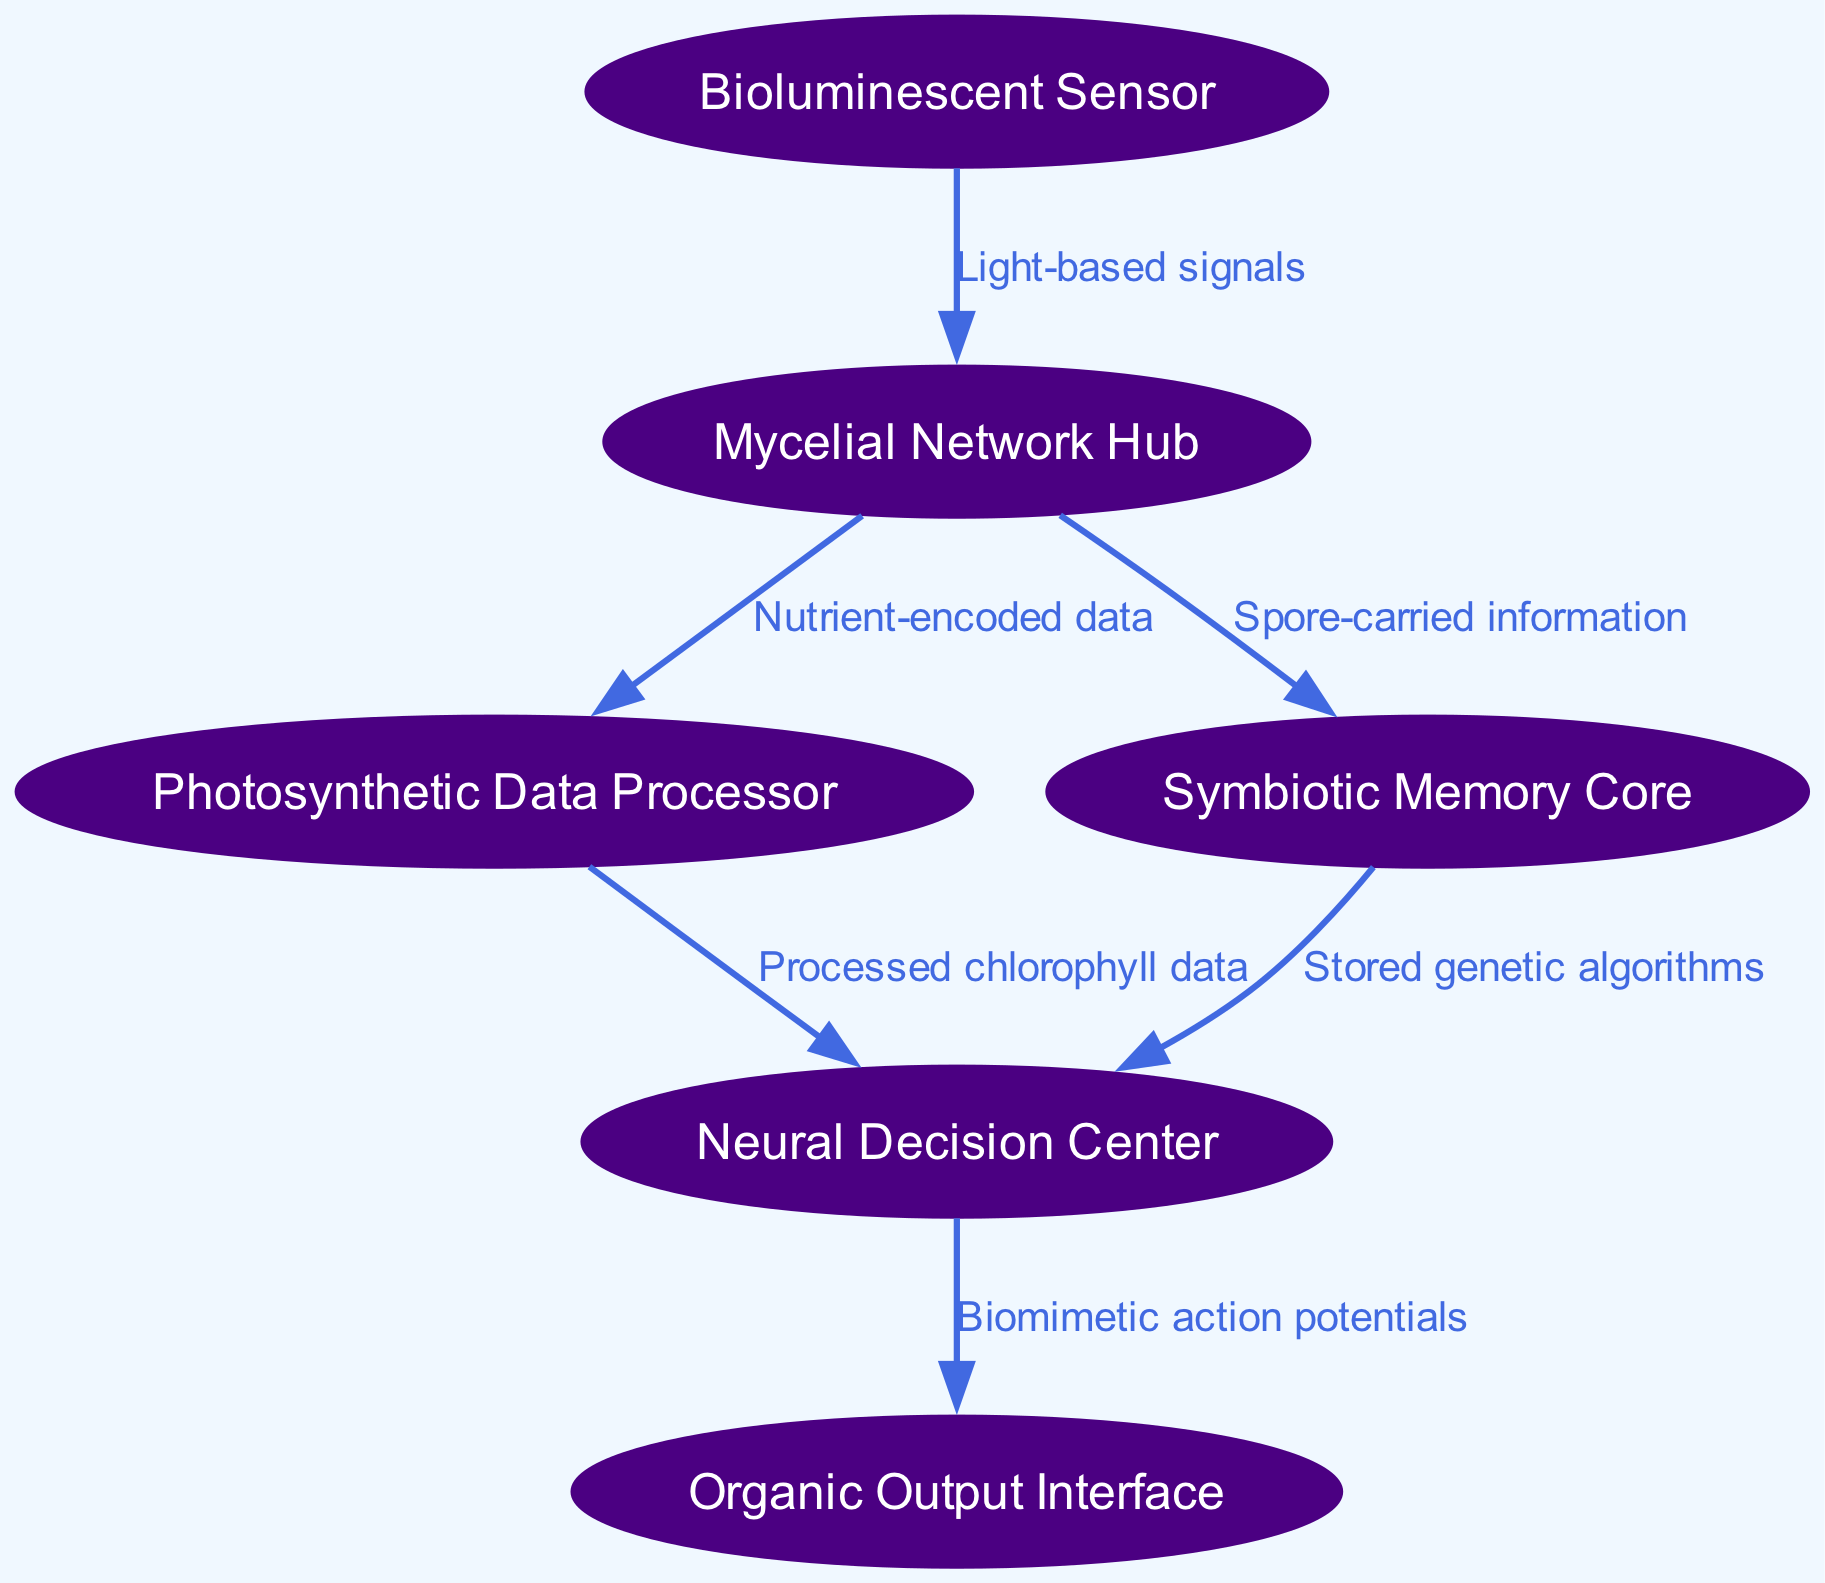What is the total number of nodes in the diagram? By counting each entry in the 'nodes' list within the provided data, we find there are six distinct nodes labeled: Bioluminescent Sensor, Mycelial Network Hub, Photosynthetic Data Processor, Symbiotic Memory Core, Neural Decision Center, and Organic Output Interface.
Answer: 6 What type of signal does the Bioluminescent Sensor use to communicate? The label on the edge from the Bioluminescent Sensor to the Mycelial Network Hub indicates that the communication method employed is "Light-based signals."
Answer: Light-based signals Which node receives nutrient-encoded data from the Mycelial Network Hub? The directed edge from the Mycelial Network Hub shows it sends nutrient-encoded data to the Photosynthetic Data Processor, indicating that this is the node receiving such data.
Answer: Photosynthetic Data Processor How many edges connect the Neural Decision Center to other nodes? By inspecting the outgoing connections from the Neural Decision Center, the diagram shows a single edge leading to the Organic Output Interface, indicating that it is connected to only one other node.
Answer: 1 What is passed between the Symbiotic Memory Core and the Neural Decision Center? The edge from the Symbiotic Memory Core to the Neural Decision Center indicates that "Stored genetic algorithms" are transferred between these two nodes.
Answer: Stored genetic algorithms What does the Photosynthetic Data Processor send to the Neural Decision Center? The edge from the Photosynthetic Data Processor to the Neural Decision Center specifies that it passes "Processed chlorophyll data" to the decision center, which highlights the nature of the data flow in this ecosystem.
Answer: Processed chlorophyll data Which node acts as the interface for organic output in the ecosystem? The label of the last node, which receives inputs from the Neural Decision Center, is explicitly marked as the "Organic Output Interface," denoting its role in the ecosystem.
Answer: Organic Output Interface What labels the connection from the Mycelial Network Hub to the Symbiotic Memory Core? The directed edge connecting these two nodes is labeled with "Spore-carried information," indicating the nature of the information being transferred between them.
Answer: Spore-carried information What is the primary output of the Neural Decision Center? The flow from the Neural Decision Center to the Organic Output Interface is characterized by "Biomimetic action potentials," indicating that this is the nature of output generated by the decision center.
Answer: Biomimetic action potentials 